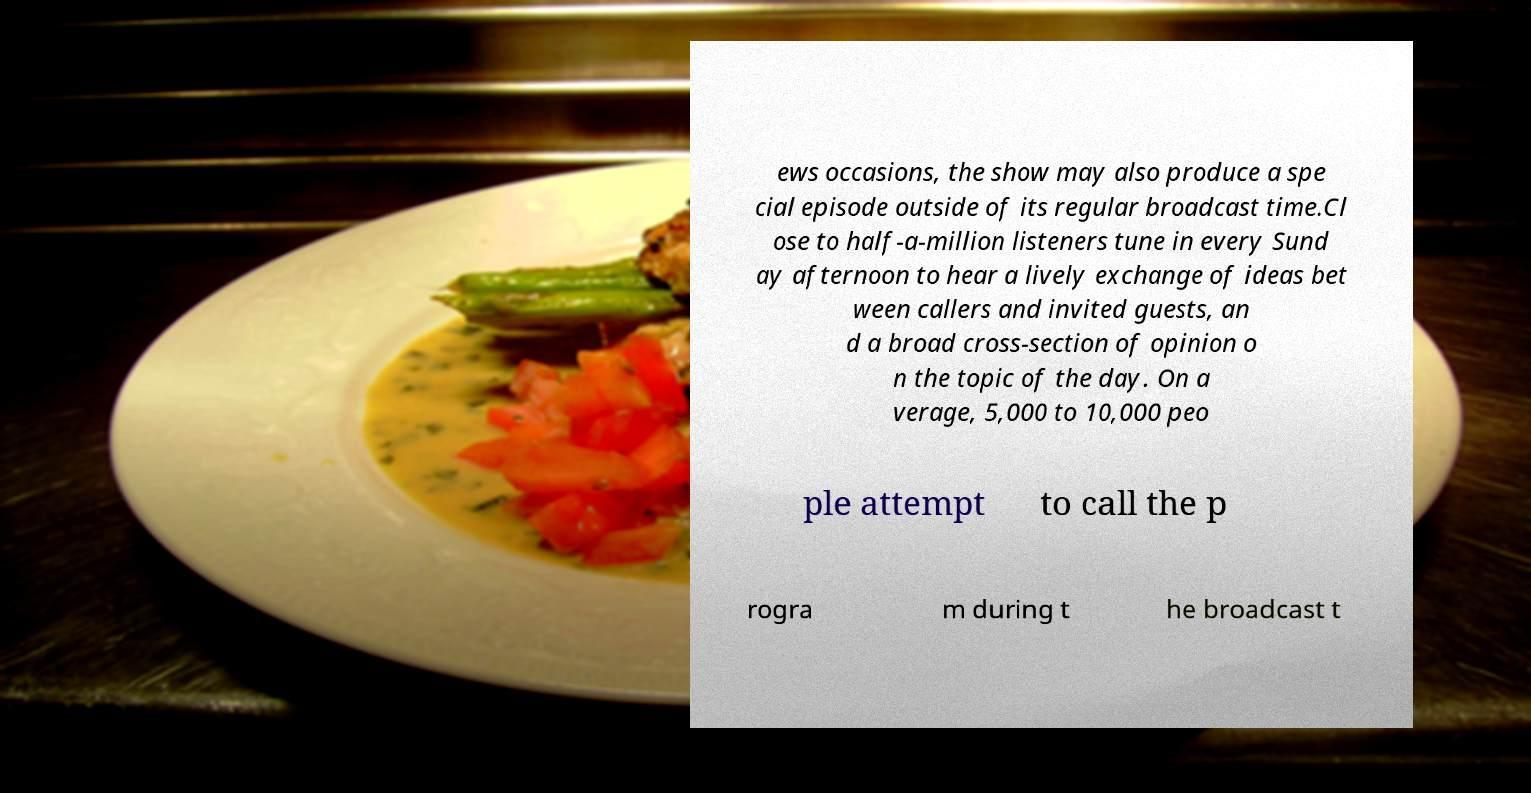I need the written content from this picture converted into text. Can you do that? ews occasions, the show may also produce a spe cial episode outside of its regular broadcast time.Cl ose to half-a-million listeners tune in every Sund ay afternoon to hear a lively exchange of ideas bet ween callers and invited guests, an d a broad cross-section of opinion o n the topic of the day. On a verage, 5,000 to 10,000 peo ple attempt to call the p rogra m during t he broadcast t 